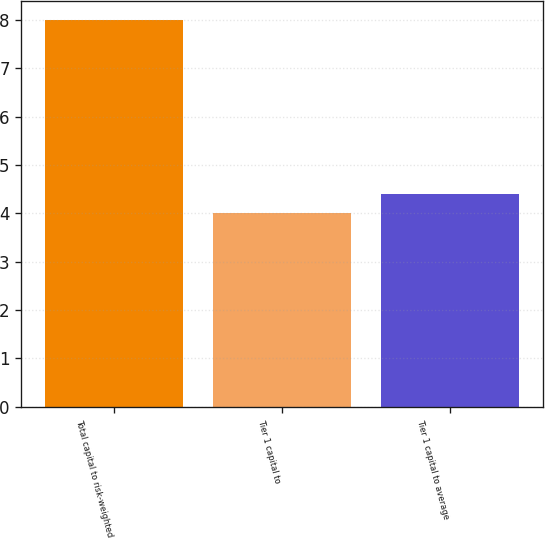Convert chart. <chart><loc_0><loc_0><loc_500><loc_500><bar_chart><fcel>Total capital to risk-weighted<fcel>Tier 1 capital to<fcel>Tier 1 capital to average<nl><fcel>8<fcel>4<fcel>4.4<nl></chart> 